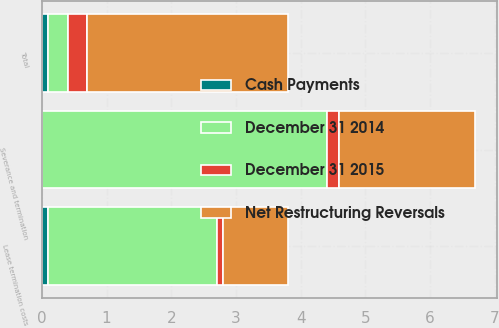Convert chart to OTSL. <chart><loc_0><loc_0><loc_500><loc_500><stacked_bar_chart><ecel><fcel>Severance and termination<fcel>Lease termination costs<fcel>Total<nl><fcel>December 31 2014<fcel>4.4<fcel>2.6<fcel>0.3<nl><fcel>Cash Payments<fcel>0<fcel>0.1<fcel>0.1<nl><fcel>Net Restructuring Reversals<fcel>2.1<fcel>1<fcel>3.1<nl><fcel>December 31 2015<fcel>0.2<fcel>0.1<fcel>0.3<nl></chart> 